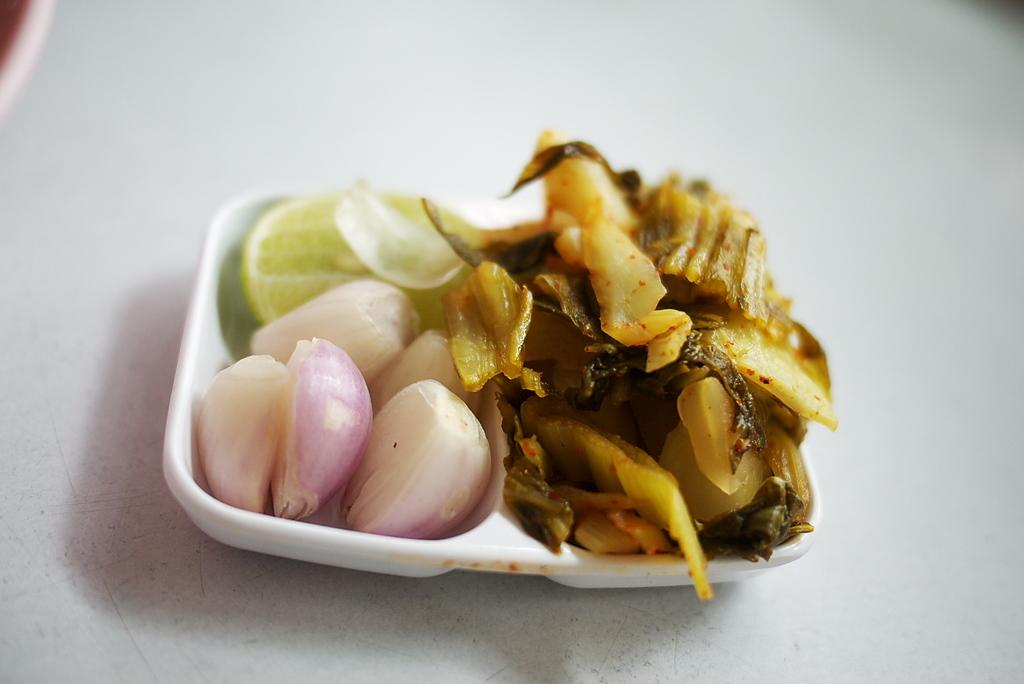What is present on the table in the image? There is a bowl on the table in the image. What is inside the bowl? The bowl contains lemon slices and onions. What type of food is in the bowl? The bowl contains food, specifically lemon slices and onions. What type of pancake is being prepared by the sister in the image? There is no pancake or sister present in the image. How many fingers can be seen touching the lemon slices in the image? There is no hand or fingers visible in the image, so it is impossible to determine the number of fingers touching the lemon slices. 